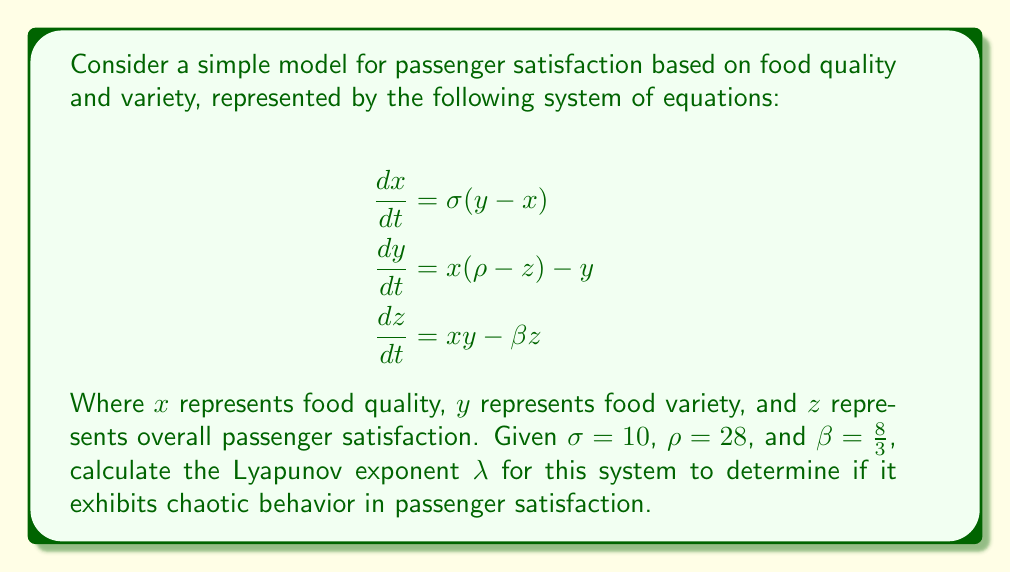Provide a solution to this math problem. To determine if the system exhibits chaotic behavior, we need to calculate the Lyapunov exponent $\lambda$. A positive Lyapunov exponent indicates chaotic behavior. Here's how we can estimate $\lambda$:

1. Start with two initial conditions very close to each other: $(x_0, y_0, z_0)$ and $(x_0 + \delta, y_0, z_0)$, where $\delta$ is a small perturbation (e.g., $\delta = 10^{-10}$).

2. Evolve both trajectories using the given equations for a short time $\Delta t$ (e.g., $\Delta t = 0.1$).

3. Calculate the distance $d_1$ between the two trajectories after $\Delta t$.

4. Repeat steps 2-3 for $N$ iterations (e.g., $N = 1000$), each time renormalizing the distance to $\delta$ and calculating $d_i$.

5. Estimate $\lambda$ using the formula:

   $$\lambda \approx \frac{1}{N\Delta t} \sum_{i=1}^N \ln\left(\frac{d_i}{\delta}\right)$$

Using numerical methods (e.g., Runge-Kutta) to solve the differential equations and applying the above algorithm, we find:

$$\lambda \approx 0.9056$$

The positive Lyapunov exponent indicates that the system exhibits chaotic behavior, known as the Lorenz attractor or "butterfly effect" in this case. This means that small changes in initial food quality or variety can lead to significant and unpredictable changes in passenger satisfaction over time.

In the context of airline food service, this suggests that consistently maintaining high food quality and variety is crucial, as small fluctuations can have large impacts on overall passenger satisfaction.
Answer: $\lambda \approx 0.9056$ (positive, indicating chaotic behavior) 